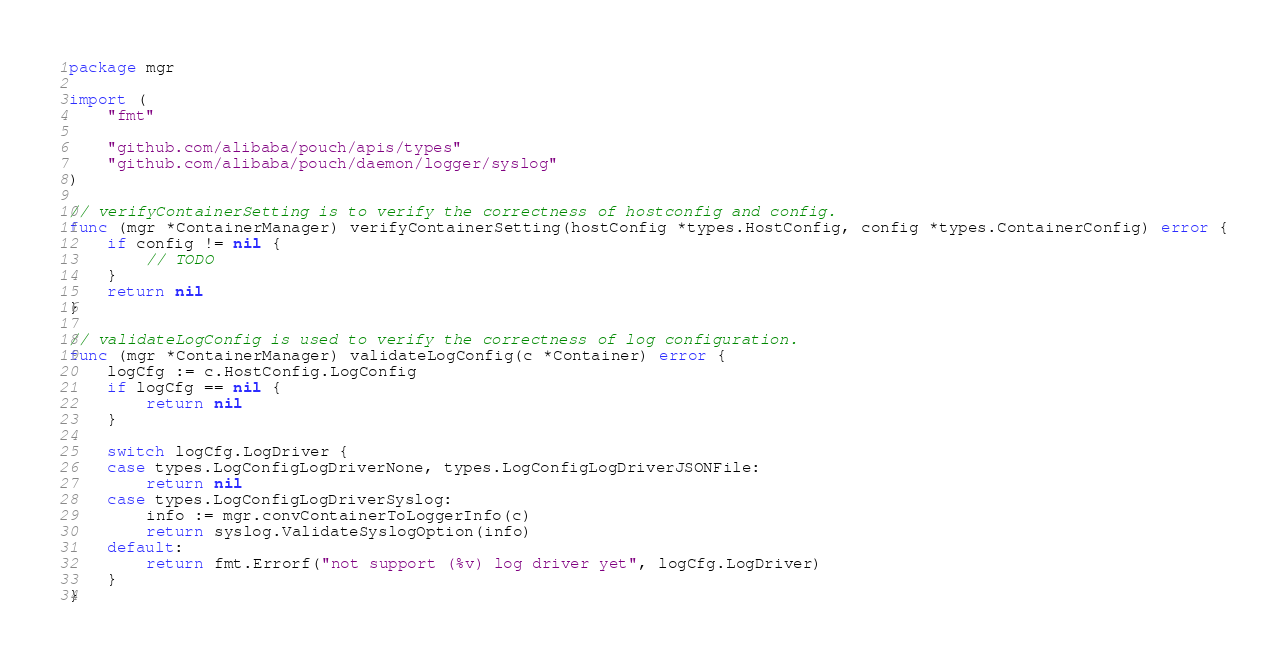<code> <loc_0><loc_0><loc_500><loc_500><_Go_>package mgr

import (
	"fmt"

	"github.com/alibaba/pouch/apis/types"
	"github.com/alibaba/pouch/daemon/logger/syslog"
)

// verifyContainerSetting is to verify the correctness of hostconfig and config.
func (mgr *ContainerManager) verifyContainerSetting(hostConfig *types.HostConfig, config *types.ContainerConfig) error {
	if config != nil {
		// TODO
	}
	return nil
}

// validateLogConfig is used to verify the correctness of log configuration.
func (mgr *ContainerManager) validateLogConfig(c *Container) error {
	logCfg := c.HostConfig.LogConfig
	if logCfg == nil {
		return nil
	}

	switch logCfg.LogDriver {
	case types.LogConfigLogDriverNone, types.LogConfigLogDriverJSONFile:
		return nil
	case types.LogConfigLogDriverSyslog:
		info := mgr.convContainerToLoggerInfo(c)
		return syslog.ValidateSyslogOption(info)
	default:
		return fmt.Errorf("not support (%v) log driver yet", logCfg.LogDriver)
	}
}
</code> 